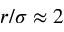Convert formula to latex. <formula><loc_0><loc_0><loc_500><loc_500>r / \sigma \approx 2</formula> 